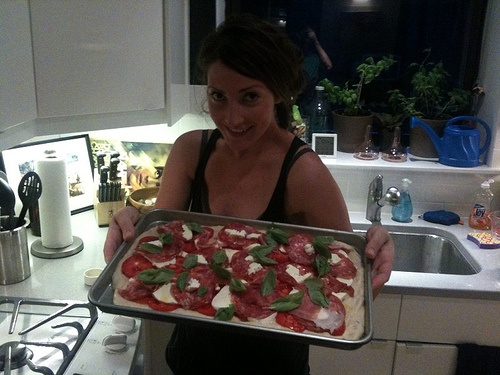Describe the objects in this image and their specific colors. I can see people in gray, black, maroon, and brown tones, pizza in gray, maroon, and black tones, oven in gray, lightgray, darkgray, and black tones, sink in gray, black, purple, and darkgray tones, and potted plant in gray, black, navy, and darkgreen tones in this image. 